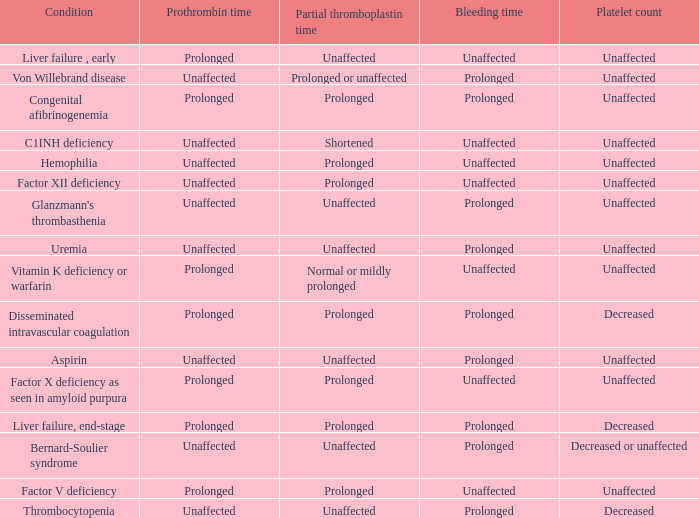Which Platelet count has a Condition of factor v deficiency? Unaffected. 